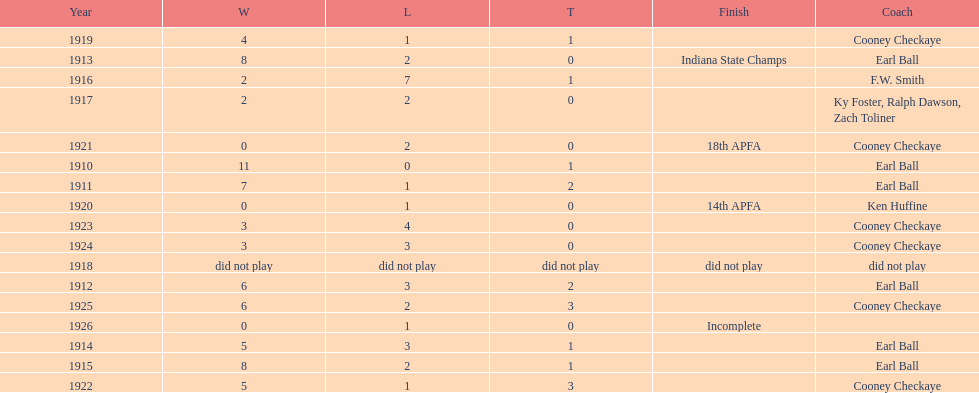How many years did earl ball coach the muncie flyers? 6. 